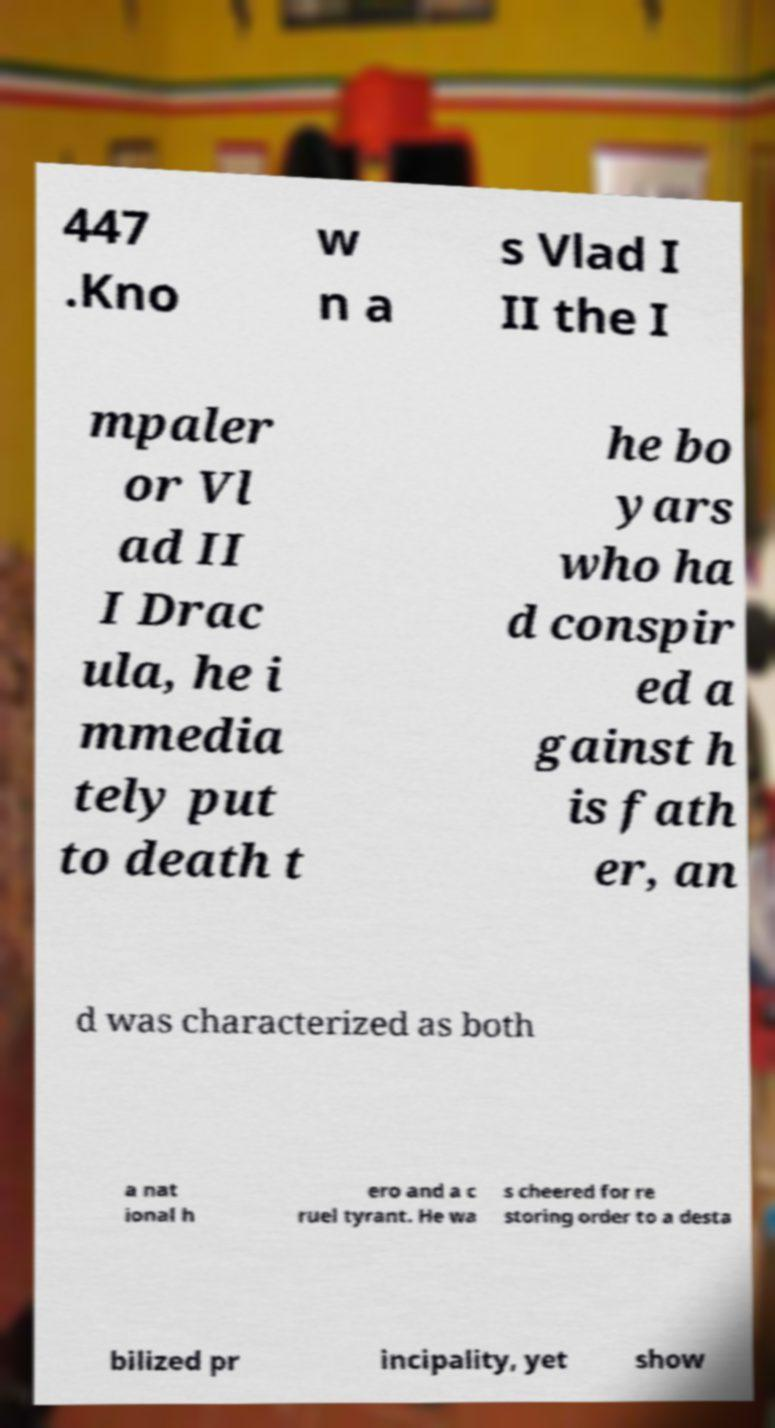Please identify and transcribe the text found in this image. 447 .Kno w n a s Vlad I II the I mpaler or Vl ad II I Drac ula, he i mmedia tely put to death t he bo yars who ha d conspir ed a gainst h is fath er, an d was characterized as both a nat ional h ero and a c ruel tyrant. He wa s cheered for re storing order to a desta bilized pr incipality, yet show 